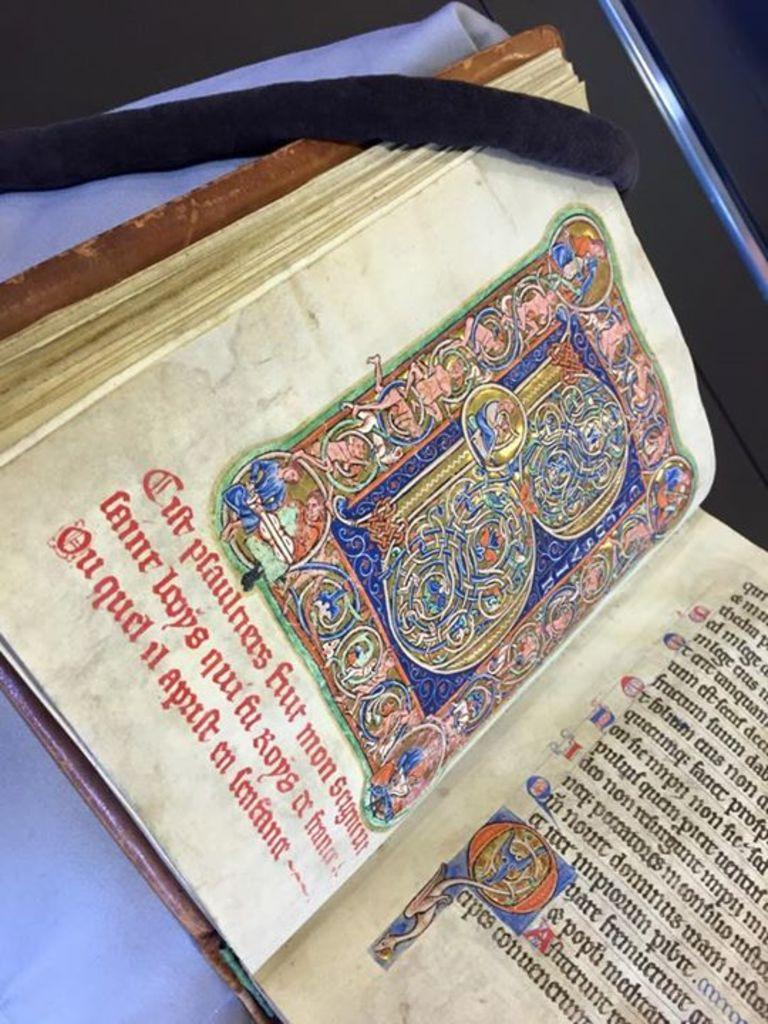<image>
Present a compact description of the photo's key features. A book where two pages can be seen, with the left side having foreign text. 